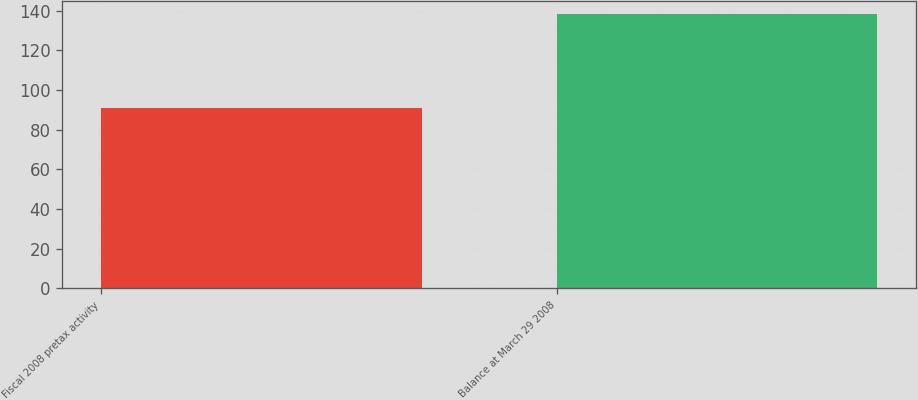Convert chart to OTSL. <chart><loc_0><loc_0><loc_500><loc_500><bar_chart><fcel>Fiscal 2008 pretax activity<fcel>Balance at March 29 2008<nl><fcel>90.8<fcel>138.1<nl></chart> 